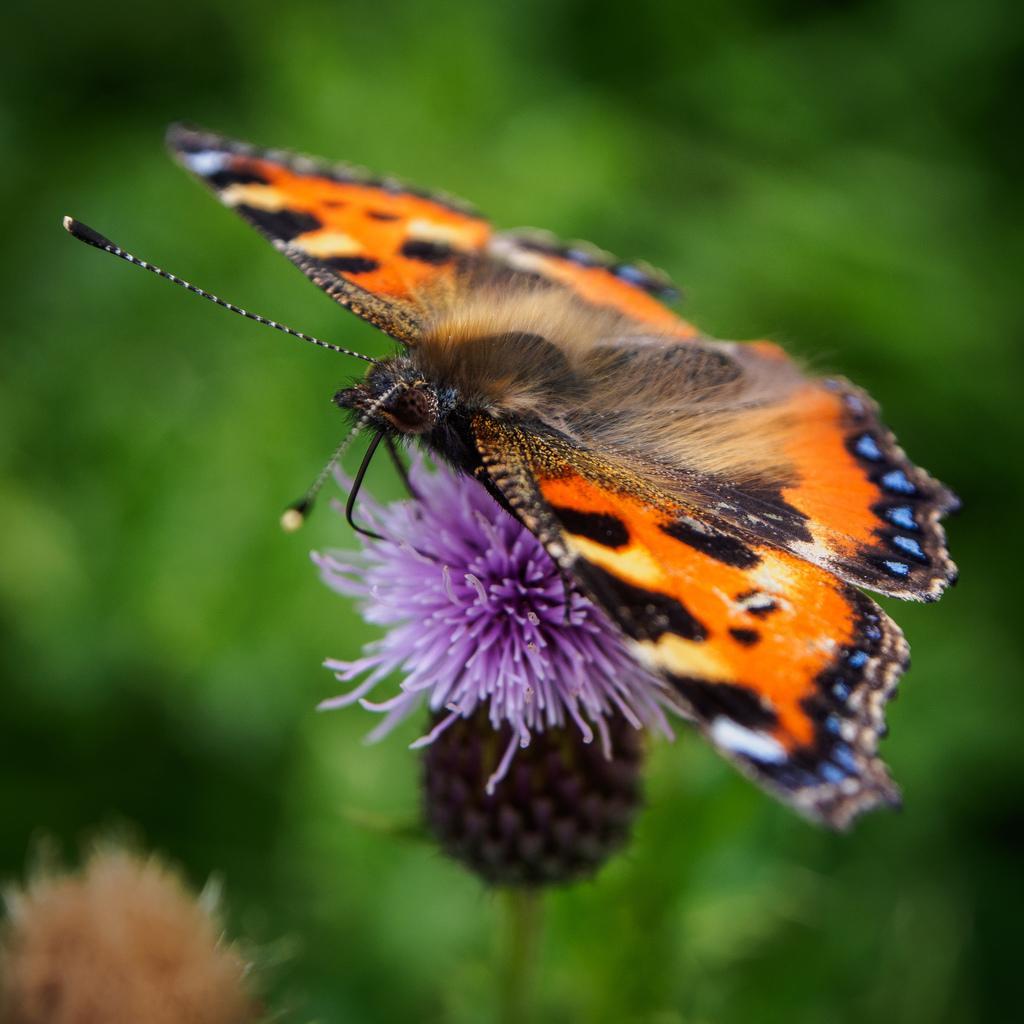In one or two sentences, can you explain what this image depicts? In the center of the image we can see a butterfly is present on a flower. In the bottom left corner we can see a flower. In the background the image is blur. 